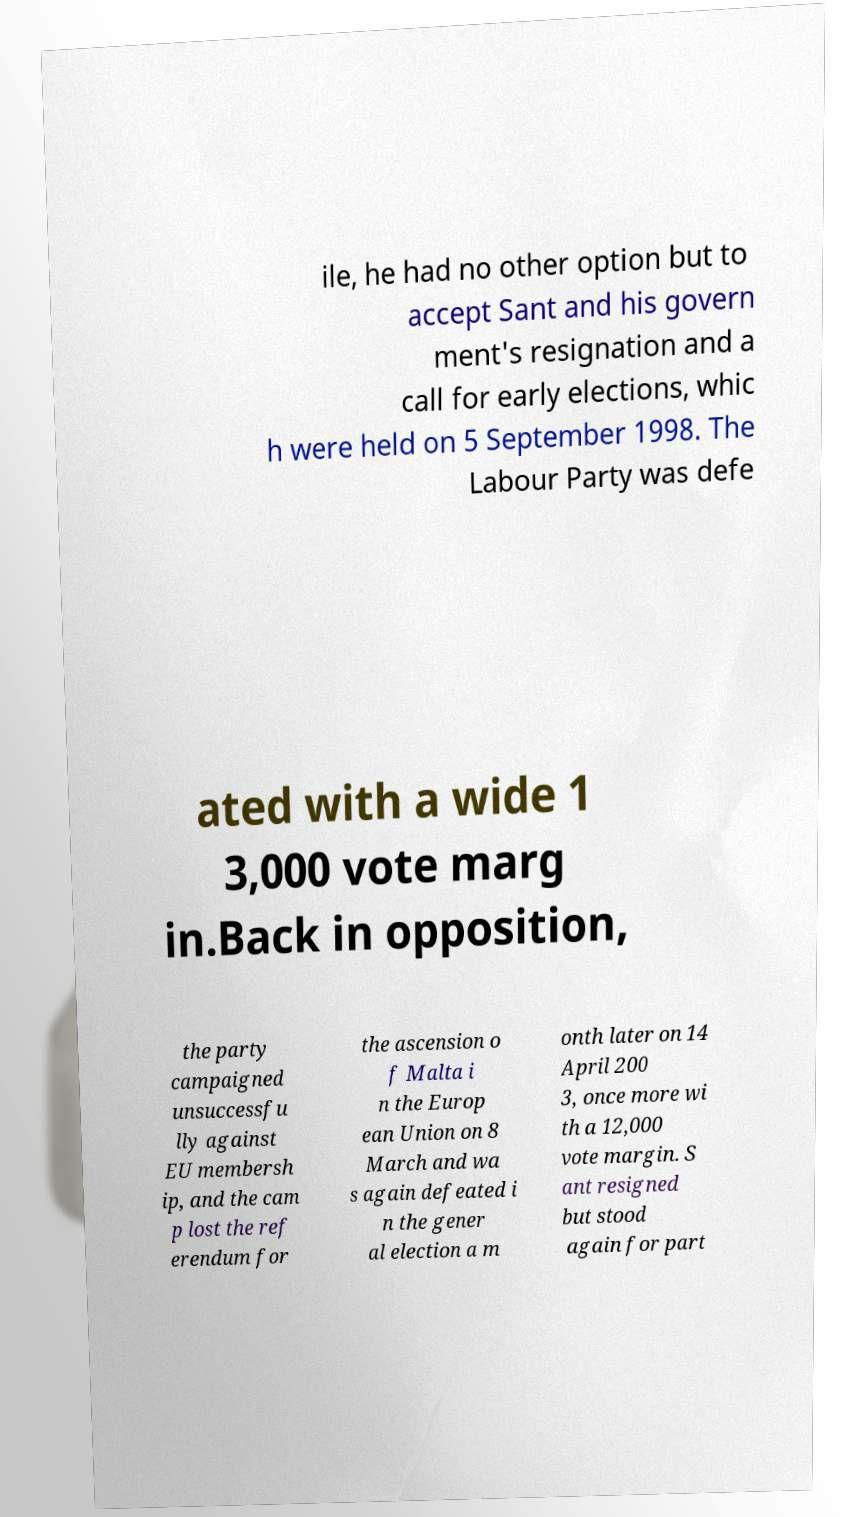Please read and relay the text visible in this image. What does it say? ile, he had no other option but to accept Sant and his govern ment's resignation and a call for early elections, whic h were held on 5 September 1998. The Labour Party was defe ated with a wide 1 3,000 vote marg in.Back in opposition, the party campaigned unsuccessfu lly against EU membersh ip, and the cam p lost the ref erendum for the ascension o f Malta i n the Europ ean Union on 8 March and wa s again defeated i n the gener al election a m onth later on 14 April 200 3, once more wi th a 12,000 vote margin. S ant resigned but stood again for part 